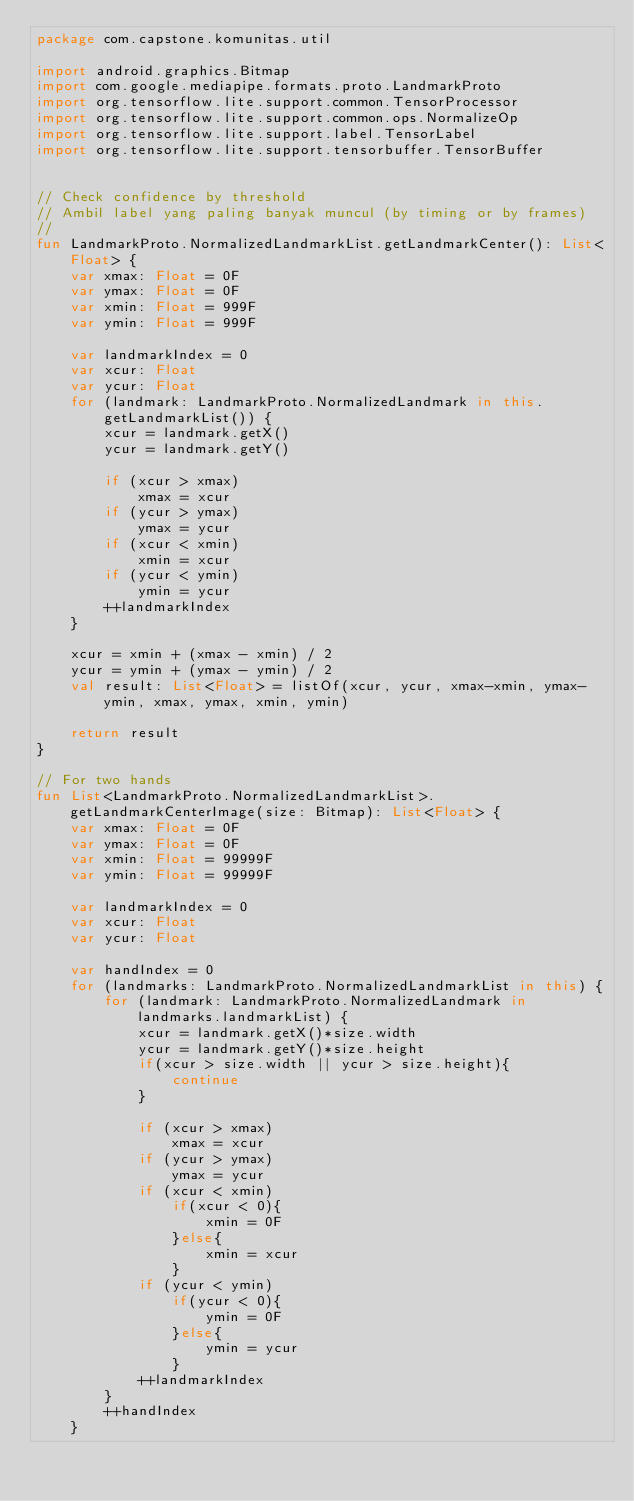<code> <loc_0><loc_0><loc_500><loc_500><_Kotlin_>package com.capstone.komunitas.util

import android.graphics.Bitmap
import com.google.mediapipe.formats.proto.LandmarkProto
import org.tensorflow.lite.support.common.TensorProcessor
import org.tensorflow.lite.support.common.ops.NormalizeOp
import org.tensorflow.lite.support.label.TensorLabel
import org.tensorflow.lite.support.tensorbuffer.TensorBuffer


// Check confidence by threshold
// Ambil label yang paling banyak muncul (by timing or by frames)
//
fun LandmarkProto.NormalizedLandmarkList.getLandmarkCenter(): List<Float> {
    var xmax: Float = 0F
    var ymax: Float = 0F
    var xmin: Float = 999F
    var ymin: Float = 999F

    var landmarkIndex = 0
    var xcur: Float
    var ycur: Float
    for (landmark: LandmarkProto.NormalizedLandmark in this.getLandmarkList()) {
        xcur = landmark.getX()
        ycur = landmark.getY()

        if (xcur > xmax)
            xmax = xcur
        if (ycur > ymax)
            ymax = ycur
        if (xcur < xmin)
            xmin = xcur
        if (ycur < ymin)
            ymin = ycur
        ++landmarkIndex
    }

    xcur = xmin + (xmax - xmin) / 2
    ycur = ymin + (ymax - ymin) / 2
    val result: List<Float> = listOf(xcur, ycur, xmax-xmin, ymax-ymin, xmax, ymax, xmin, ymin)

    return result
}

// For two hands
fun List<LandmarkProto.NormalizedLandmarkList>.getLandmarkCenterImage(size: Bitmap): List<Float> {
    var xmax: Float = 0F
    var ymax: Float = 0F
    var xmin: Float = 99999F
    var ymin: Float = 99999F

    var landmarkIndex = 0
    var xcur: Float
    var ycur: Float

    var handIndex = 0
    for (landmarks: LandmarkProto.NormalizedLandmarkList in this) {
        for (landmark: LandmarkProto.NormalizedLandmark in landmarks.landmarkList) {
            xcur = landmark.getX()*size.width
            ycur = landmark.getY()*size.height
            if(xcur > size.width || ycur > size.height){
                continue
            }

            if (xcur > xmax)
                xmax = xcur
            if (ycur > ymax)
                ymax = ycur
            if (xcur < xmin)
                if(xcur < 0){
                    xmin = 0F
                }else{
                    xmin = xcur
                }
            if (ycur < ymin)
                if(ycur < 0){
                    ymin = 0F
                }else{
                    ymin = ycur
                }
            ++landmarkIndex
        }
        ++handIndex
    }
</code> 